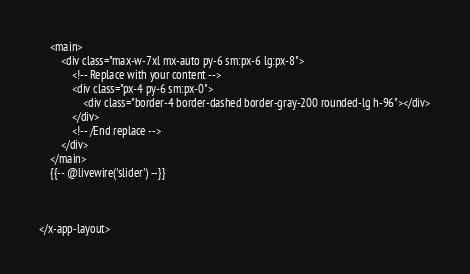<code> <loc_0><loc_0><loc_500><loc_500><_PHP_>    <main>
        <div class="max-w-7xl mx-auto py-6 sm:px-6 lg:px-8">
            <!-- Replace with your content -->
            <div class="px-4 py-6 sm:px-0">
                <div class="border-4 border-dashed border-gray-200 rounded-lg h-96"></div>
            </div>
            <!-- /End replace -->
        </div>
    </main>
    {{-- @livewire('slider') --}}



</x-app-layout></code> 